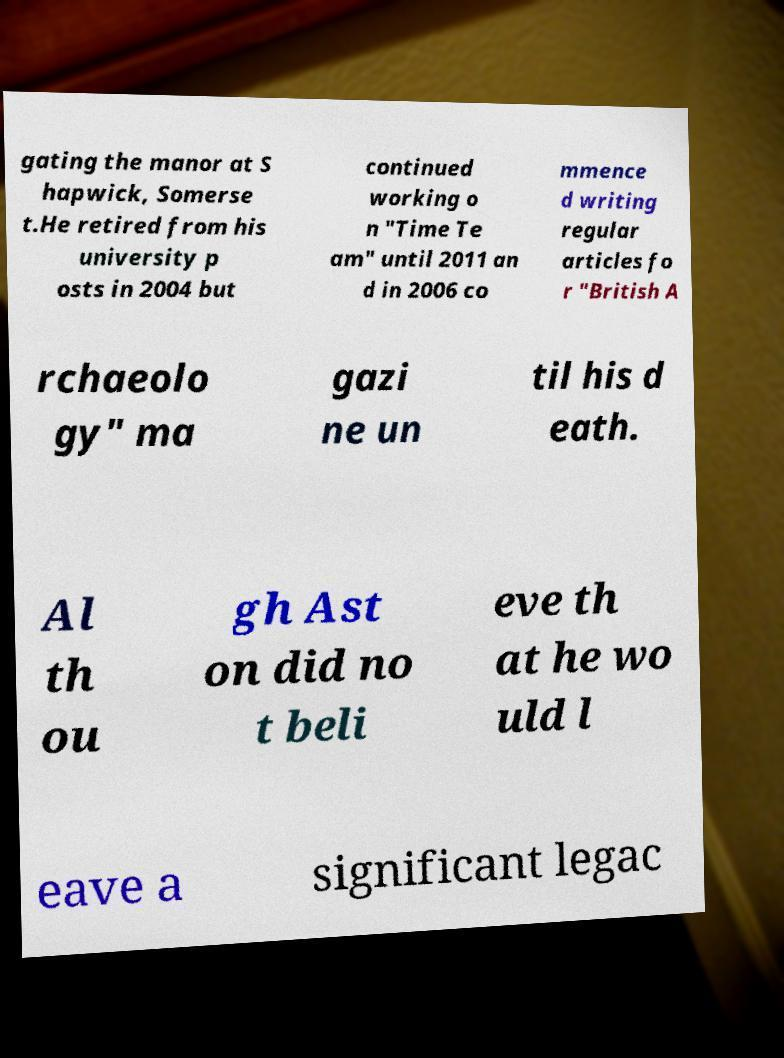I need the written content from this picture converted into text. Can you do that? gating the manor at S hapwick, Somerse t.He retired from his university p osts in 2004 but continued working o n "Time Te am" until 2011 an d in 2006 co mmence d writing regular articles fo r "British A rchaeolo gy" ma gazi ne un til his d eath. Al th ou gh Ast on did no t beli eve th at he wo uld l eave a significant legac 